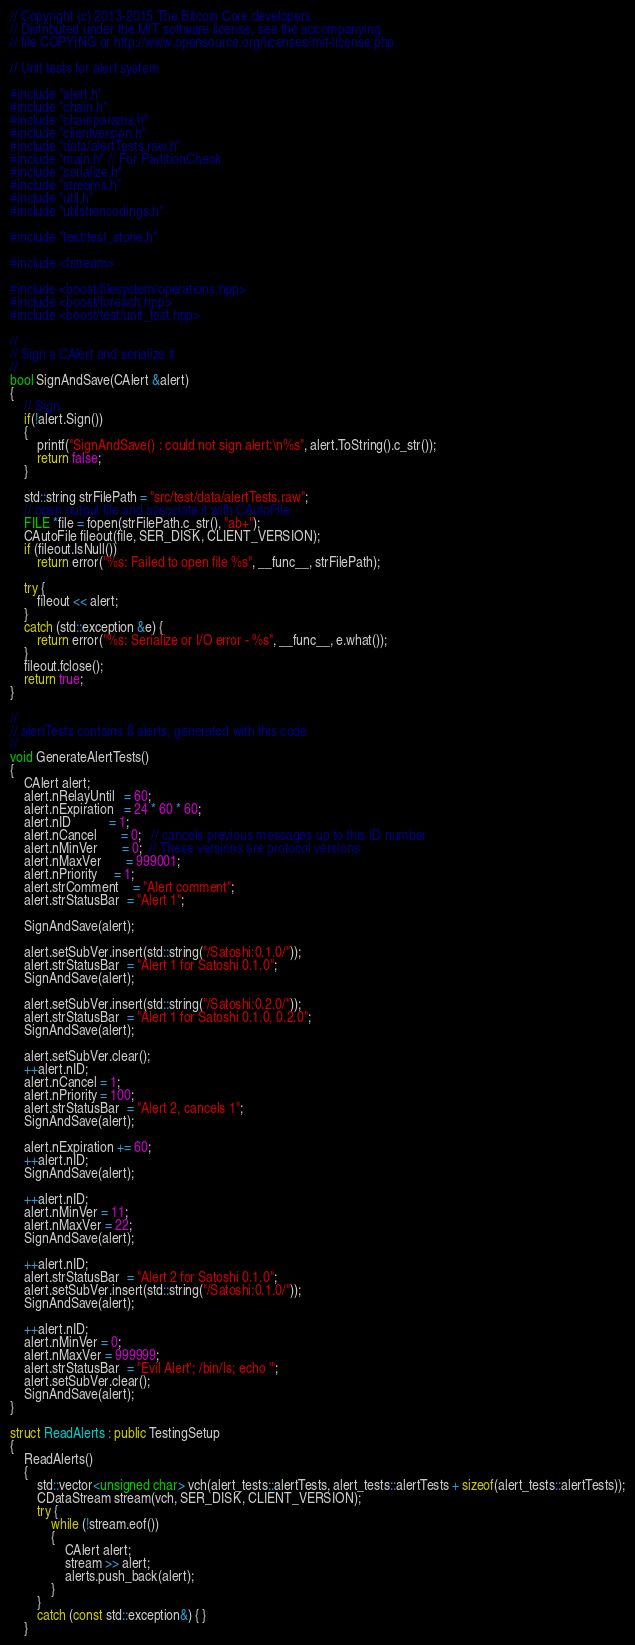<code> <loc_0><loc_0><loc_500><loc_500><_C++_>// Copyright (c) 2013-2015 The Bitcoin Core developers
// Distributed under the MIT software license, see the accompanying
// file COPYING or http://www.opensource.org/licenses/mit-license.php.

// Unit tests for alert system

#include "alert.h"
#include "chain.h"
#include "chainparams.h"
#include "clientversion.h"
#include "data/alertTests.raw.h"
#include "main.h" // For PartitionCheck
#include "serialize.h"
#include "streams.h"
#include "util.h"
#include "utilstrencodings.h"

#include "test/test_stone.h"

#include <fstream>

#include <boost/filesystem/operations.hpp>
#include <boost/foreach.hpp>
#include <boost/test/unit_test.hpp>

//
// Sign a CAlert and serialize it
//
bool SignAndSave(CAlert &alert)
{
    // Sign
    if(!alert.Sign())
    {
        printf("SignAndSave() : could not sign alert:\n%s", alert.ToString().c_str());
        return false;
    }

    std::string strFilePath = "src/test/data/alertTests.raw";
    // open output file and associate it with CAutoFile
    FILE *file = fopen(strFilePath.c_str(), "ab+");
    CAutoFile fileout(file, SER_DISK, CLIENT_VERSION);
    if (fileout.IsNull())
        return error("%s: Failed to open file %s", __func__, strFilePath);

    try {
        fileout << alert;
    }
    catch (std::exception &e) {
        return error("%s: Serialize or I/O error - %s", __func__, e.what());
    }
    fileout.fclose();
    return true;
}

//
// alertTests contains 8 alerts, generated with this code
//
void GenerateAlertTests()
{
    CAlert alert;
    alert.nRelayUntil   = 60;
    alert.nExpiration   = 24 * 60 * 60;
    alert.nID           = 1;
    alert.nCancel       = 0;   // cancels previous messages up to this ID number
    alert.nMinVer       = 0;  // These versions are protocol versions
    alert.nMaxVer       = 999001;
    alert.nPriority     = 1;
    alert.strComment    = "Alert comment";
    alert.strStatusBar  = "Alert 1";

    SignAndSave(alert);

    alert.setSubVer.insert(std::string("/Satoshi:0.1.0/"));
    alert.strStatusBar  = "Alert 1 for Satoshi 0.1.0";
    SignAndSave(alert);

    alert.setSubVer.insert(std::string("/Satoshi:0.2.0/"));
    alert.strStatusBar  = "Alert 1 for Satoshi 0.1.0, 0.2.0";
    SignAndSave(alert);

    alert.setSubVer.clear();
    ++alert.nID;
    alert.nCancel = 1;
    alert.nPriority = 100;
    alert.strStatusBar  = "Alert 2, cancels 1";
    SignAndSave(alert);

    alert.nExpiration += 60;
    ++alert.nID;
    SignAndSave(alert);

    ++alert.nID;
    alert.nMinVer = 11;
    alert.nMaxVer = 22;
    SignAndSave(alert);

    ++alert.nID;
    alert.strStatusBar  = "Alert 2 for Satoshi 0.1.0";
    alert.setSubVer.insert(std::string("/Satoshi:0.1.0/"));
    SignAndSave(alert);

    ++alert.nID;
    alert.nMinVer = 0;
    alert.nMaxVer = 999999;
    alert.strStatusBar  = "Evil Alert'; /bin/ls; echo '";
    alert.setSubVer.clear();
    SignAndSave(alert);
}

struct ReadAlerts : public TestingSetup
{
    ReadAlerts()
    {
        std::vector<unsigned char> vch(alert_tests::alertTests, alert_tests::alertTests + sizeof(alert_tests::alertTests));
        CDataStream stream(vch, SER_DISK, CLIENT_VERSION);
        try {
            while (!stream.eof())
            {
                CAlert alert;
                stream >> alert;
                alerts.push_back(alert);
            }
        }
        catch (const std::exception&) { }
    }</code> 